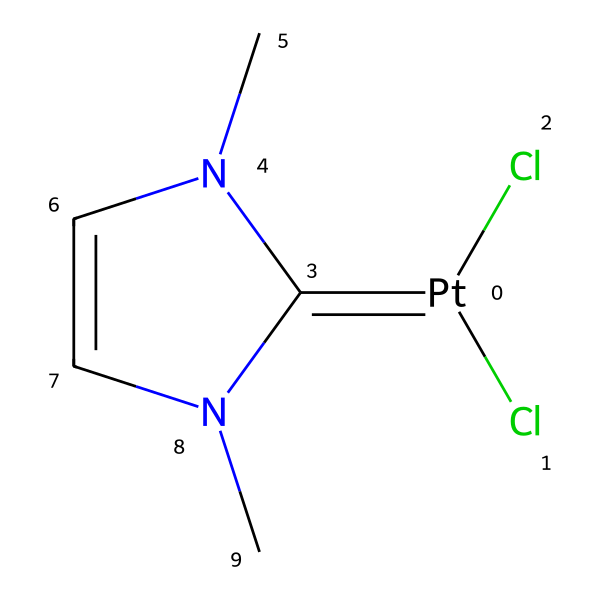What is the central metal in this carbene complex? The chemical structure shows the presence of platinum, which is evident from the '[Pt]' notation at the beginning of the SMILES representation.
Answer: platinum How many carbon atoms are present in this structure? Counting the carbon atoms in the SMILES string reveals four carbon atoms; they are indicated by the 'C' in the structure twice, and from the nitrogen and chloride connections, we can infer there are two additional carbons.
Answer: four What type of bond is indicated between the platinum and the adjacent carbon? The '=' in the SMILES indicates a double bond between the platinum and the carbon atom, which is characteristic of carbene complexes.
Answer: double bond What is the number of nitrogen atoms in this chemical? The SMILES shows 'N' twice, indicating that there are two nitrogen atoms in the complex, with both connected to the cyclic structure.
Answer: two Does this carbene have any substituent groups? By analyzing the SMILES, we see that there are chlorine atoms ('Cl') as substituents attached to the platinum center, showing that substituents are indeed present.
Answer: yes What type of complex is this molecule classified as? The presence of a carbene group (the '=C' part) and a metal center like platinum indicates this is classified as a carbene complex.
Answer: carbene complex How many chlorine atoms are present in the structure? The notation '(Cl)(Cl)' directly following the platinum indicates there are two chlorine atoms attached to the central metal.
Answer: two 